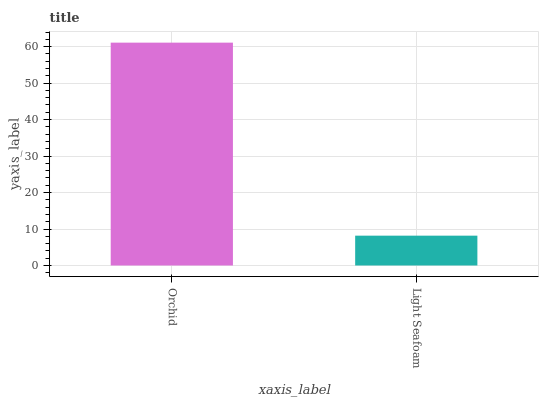Is Light Seafoam the maximum?
Answer yes or no. No. Is Orchid greater than Light Seafoam?
Answer yes or no. Yes. Is Light Seafoam less than Orchid?
Answer yes or no. Yes. Is Light Seafoam greater than Orchid?
Answer yes or no. No. Is Orchid less than Light Seafoam?
Answer yes or no. No. Is Orchid the high median?
Answer yes or no. Yes. Is Light Seafoam the low median?
Answer yes or no. Yes. Is Light Seafoam the high median?
Answer yes or no. No. Is Orchid the low median?
Answer yes or no. No. 